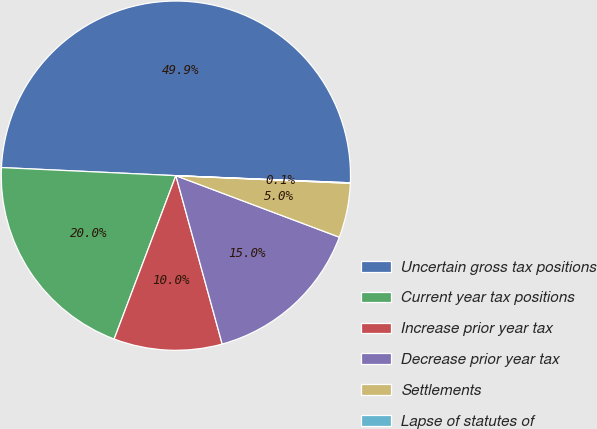Convert chart. <chart><loc_0><loc_0><loc_500><loc_500><pie_chart><fcel>Uncertain gross tax positions<fcel>Current year tax positions<fcel>Increase prior year tax<fcel>Decrease prior year tax<fcel>Settlements<fcel>Lapse of statutes of<nl><fcel>49.91%<fcel>19.99%<fcel>10.02%<fcel>15.0%<fcel>5.03%<fcel>0.05%<nl></chart> 